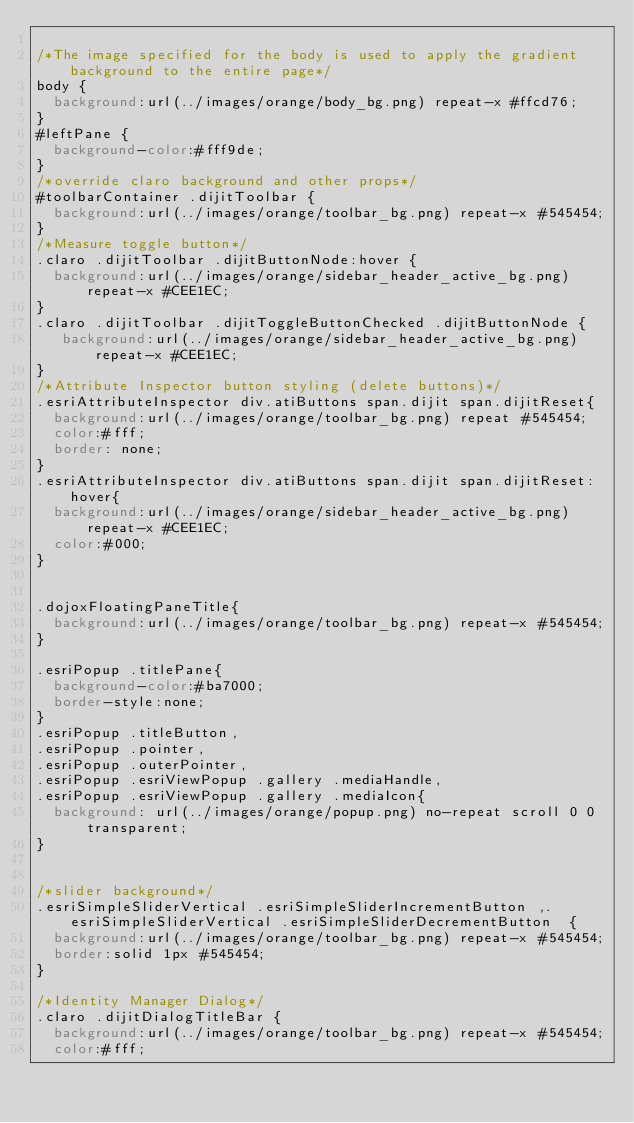Convert code to text. <code><loc_0><loc_0><loc_500><loc_500><_CSS_>
/*The image specified for the body is used to apply the gradient background to the entire page*/
body {
  background:url(../images/orange/body_bg.png) repeat-x #ffcd76;
}
#leftPane {
  background-color:#fff9de;
}
/*override claro background and other props*/
#toolbarContainer .dijitToolbar {
  background:url(../images/orange/toolbar_bg.png) repeat-x #545454;
}
/*Measure toggle button*/
.claro .dijitToolbar .dijitButtonNode:hover {
  background:url(../images/orange/sidebar_header_active_bg.png) repeat-x #CEE1EC;
}
.claro .dijitToolbar .dijitToggleButtonChecked .dijitButtonNode {
   background:url(../images/orange/sidebar_header_active_bg.png) repeat-x #CEE1EC;
}
/*Attribute Inspector button styling (delete buttons)*/
.esriAttributeInspector div.atiButtons span.dijit span.dijitReset{
  background:url(../images/orange/toolbar_bg.png) repeat #545454;
  color:#fff;
  border: none;
}
.esriAttributeInspector div.atiButtons span.dijit span.dijitReset:hover{
  background:url(../images/orange/sidebar_header_active_bg.png) repeat-x #CEE1EC;
  color:#000;
}


.dojoxFloatingPaneTitle{
  background:url(../images/orange/toolbar_bg.png) repeat-x #545454;
}

.esriPopup .titlePane{
  background-color:#ba7000;
  border-style:none;
}
.esriPopup .titleButton,
.esriPopup .pointer,
.esriPopup .outerPointer,
.esriPopup .esriViewPopup .gallery .mediaHandle,
.esriPopup .esriViewPopup .gallery .mediaIcon{
  background: url(../images/orange/popup.png) no-repeat scroll 0 0 transparent;
}


/*slider background*/
.esriSimpleSliderVertical .esriSimpleSliderIncrementButton ,.esriSimpleSliderVertical .esriSimpleSliderDecrementButton  {
  background:url(../images/orange/toolbar_bg.png) repeat-x #545454;
  border:solid 1px #545454;
}

/*Identity Manager Dialog*/
.claro .dijitDialogTitleBar {
  background:url(../images/orange/toolbar_bg.png) repeat-x #545454;
  color:#fff;</code> 